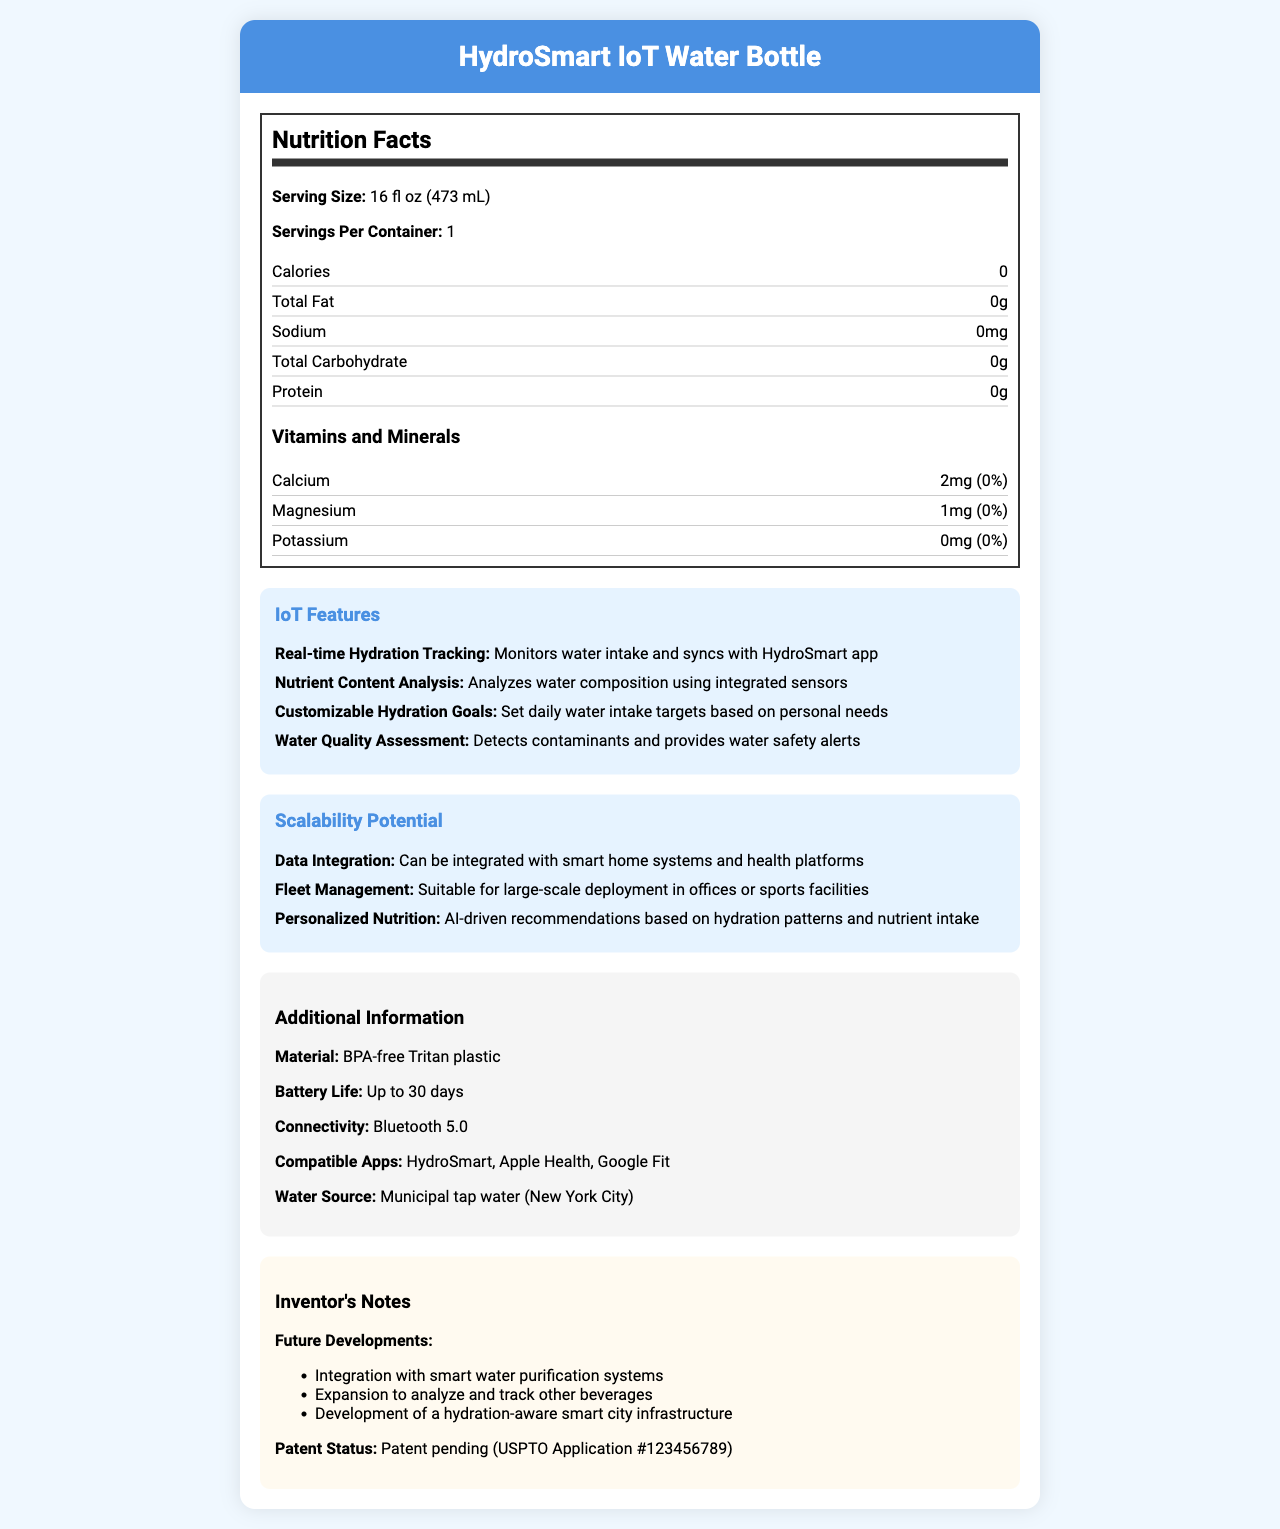what is the serving size? The serving size is clearly stated under the "Nutrition Facts" section.
Answer: 16 fl oz (473 mL) How many calories are in one serving? The calories per serving are listed as 0 in the nutrition label.
Answer: 0 What is the battery life of the HydroSmart IoT Water Bottle? This information is found under the "Additional Information" section.
Answer: Up to 30 days What is the patent status of the HydroSmart IoT Water Bottle? This detail is located in the "Inventor's Notes" section.
Answer: Patent pending (USPTO Application #123456789) Name two compatible apps for the HydroSmart IoT Water Bottle. The compatible apps are listed under "Additional Information".
Answer: HydroSmart, Apple Health What is the amount of Calcium in the HydroSmart IoT Water Bottle per serving? The amount of Calcium is specified under the "Vitamins and Minerals" subsection of "Nutrition Facts".
Answer: 2mg Which of the following is not an IoT feature of the HydroSmart IoT Water Bottle?
A. Real-time Hydration Tracking
B. Fleet Management
C. Water Quality Assessment "Fleet Management" is listed under "Scalability Potential" and not as an IoT feature.
Answer: B Which nutrient is present in the lowest quantity in the HydroSmart IoT Water Bottle?
I. Magnesium
II. Potassium
III. Calcium
IV. Protein Potassium is listed as 0mg, which is the lowest quantity among the given options.
Answer: II Is the HydroSmart IoT Water Bottle made from BPA-free Tritan plastic? This information is provided under the "Additional Information" section.
Answer: Yes Summarize the main features of the HydroSmart IoT Water Bottle. The summary captures the main features and functionalities provided by the HydroSmart IoT Water Bottle as detailed in the document.
Answer: The HydroSmart IoT Water Bottle offers a variety of features including real-time hydration tracking, nutrient content analysis, customizable hydration goals, and water quality assessment. The bottle has scalability potential with smart home integration, fleet management suitability, and personalized nutrition recommendations. Additional info includes material details, battery life, connectivity, and compatibility with popular health apps. Does the document provide the complete formula for assessing water quality? The document mentions "Water Quality Assessment" as an IoT feature but does not provide the complete formula used for the assessment.
Answer: Not enough information 